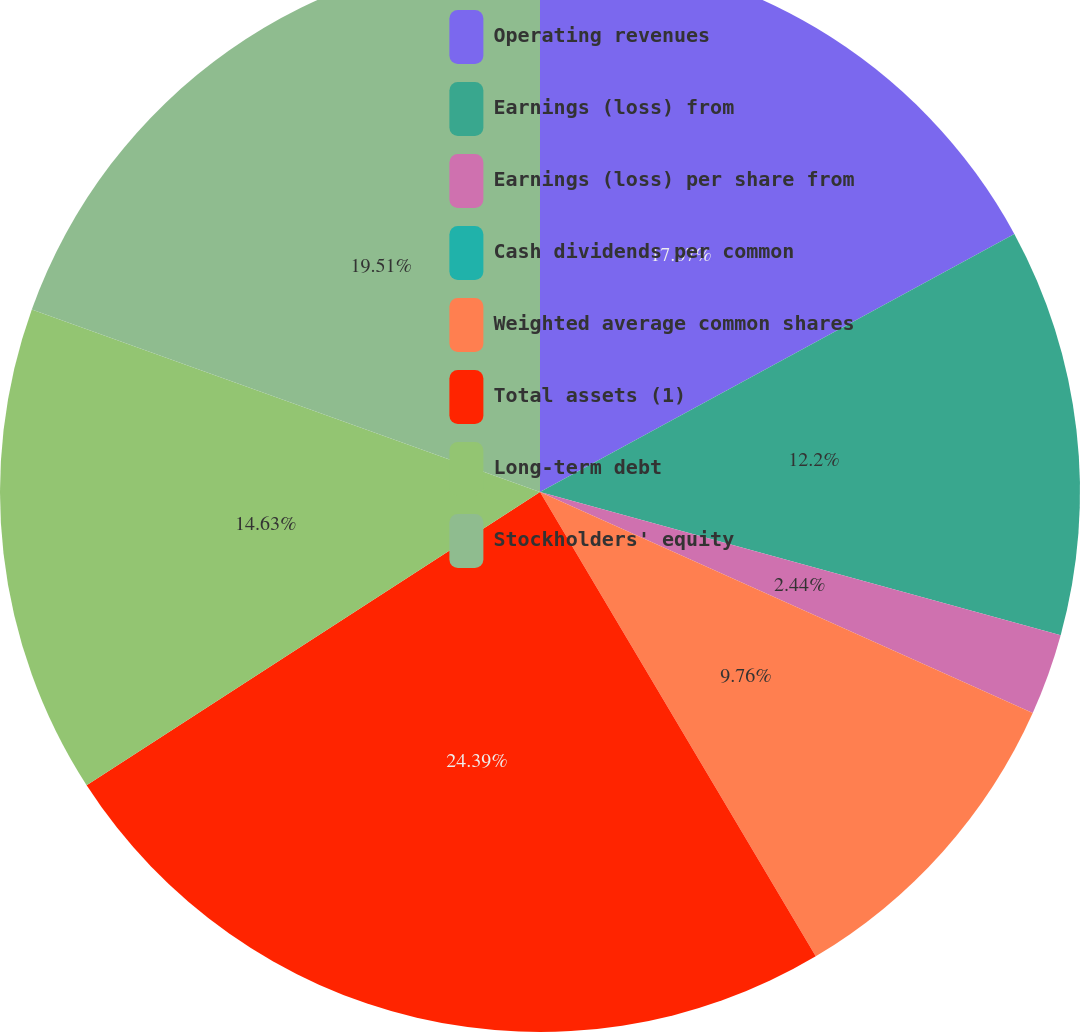Convert chart to OTSL. <chart><loc_0><loc_0><loc_500><loc_500><pie_chart><fcel>Operating revenues<fcel>Earnings (loss) from<fcel>Earnings (loss) per share from<fcel>Cash dividends per common<fcel>Weighted average common shares<fcel>Total assets (1)<fcel>Long-term debt<fcel>Stockholders' equity<nl><fcel>17.07%<fcel>12.2%<fcel>2.44%<fcel>0.0%<fcel>9.76%<fcel>24.39%<fcel>14.63%<fcel>19.51%<nl></chart> 